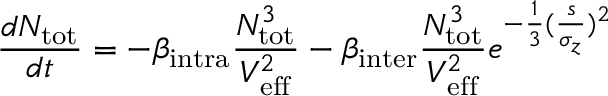Convert formula to latex. <formula><loc_0><loc_0><loc_500><loc_500>\frac { d N _ { t o t } } { d t } = - \beta _ { i n t r a } \frac { N _ { t o t } ^ { 3 } } { V _ { e f f } ^ { 2 } } - \beta _ { i n t e r } \frac { N _ { t o t } ^ { 3 } } { V _ { e f f } ^ { 2 } } e ^ { - \frac { 1 } { 3 } ( \frac { s } { \sigma _ { z } } ) ^ { 2 } }</formula> 